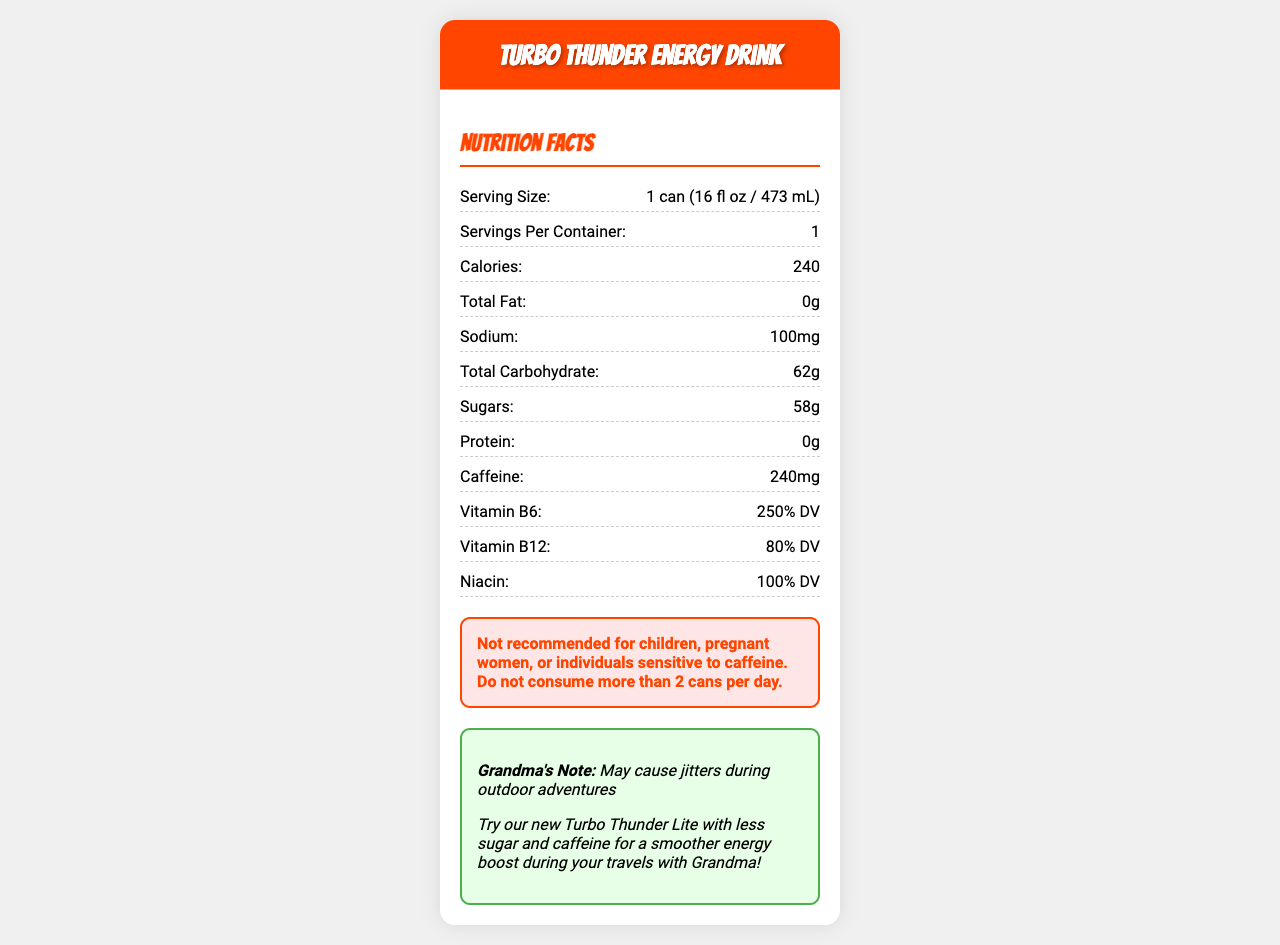what is the serving size? The serving size is mentioned in the nutrition facts under the "Serving Size" section.
Answer: 1 can (16 fl oz / 473 mL) How many calories are in one serving of Turbo Thunder Energy Drink? The calories per serving is listed as 240 in the nutrition facts.
Answer: 240 What is the total carbohydrate content? The total carbohydrate content is found in the nutrition facts labeled as "Total Carbohydrate."
Answer: 62g How much sodium does one can of the energy drink contain? The sodium content is listed under the nutrition facts section.
Answer: 100mg How much sugar is in one can of this energy drink? The sugars content is provided in the nutrition facts as 58g.
Answer: 58g what is the caffeine content per serving? The caffeine content is specified as 240mg in the nutrition facts.
Answer: 240mg What is the percentage of Daily Value (DV) for Vitamin B6? The percentage DV for Vitamin B6 is noted in the nutrition facts as 250%.
Answer: 250% Does Turbo Thunder Energy Drink contain any fat? The total fat content is listed as 0g, indicating it contains no fat.
Answer: No Is it safe for children to consume Turbo Thunder Energy Drink? The warning states it is not recommended for children, pregnant women, or individuals sensitive to caffeine.
Answer: No Is this product recommended for your birthday trip with Grandma? The document mentions "May cause jitters during outdoor adventures," suggesting it may not be suitable for the trip.
Answer: No Which of the following is not an ingredient in Turbo Thunder Energy Drink? A. Taurine B. Ginseng Extract C. Protein D. Guarana Seed Extract Protein is not listed as an ingredient in the nutrition facts, while Taurine, Ginseng Extract, and Guarana Seed Extract are.
Answer: C The Turbo Thunder Energy Drink has a high content of which vitamin? A. Vitamin B6 B. Vitamin C C. Vitamin D D. Vitamin B12 The drink contains 250% DV of Vitamin B6, which is higher than other vitamins listed.
Answer: A Should you consume more than 2 cans of Turbo Thunder Energy Drink per day? The warning advises not to consume more than 2 cans per day.
Answer: No Summarize the key information provided by the document about Turbo Thunder Energy Drink. The explanation includes the main nutritional content, key ingredients, warnings, and suitability information relevant to the product.
Answer: Turbo Thunder Energy Drink provides detailed nutrition facts for a single 16 fl oz can, which includes 240 calories, 0g fat, 100mg sodium, 62g carbohydrates, 58g sugars, and 0g protein. It highlights significant amounts of caffeine, vitamins B6 and B12, niacin, taurine, ginseng extract, guarana seed extract, inositol, and L-carnitine. It comes with a warning advising against its consumption by children, pregnant women, or individuals sensitive to caffeine and suggests not consuming more than 2 cans per day. Additionally, it hints that the drink may cause jitters during outdoor adventures, recommending a lighter alternative for smoother energy. What are the potential health benefits of consuming Turbo Thunder Energy Drink's ingredients? The document lists the ingredients and their amounts but does not provide specific health benefits for each ingredient.
Answer: Not enough information 